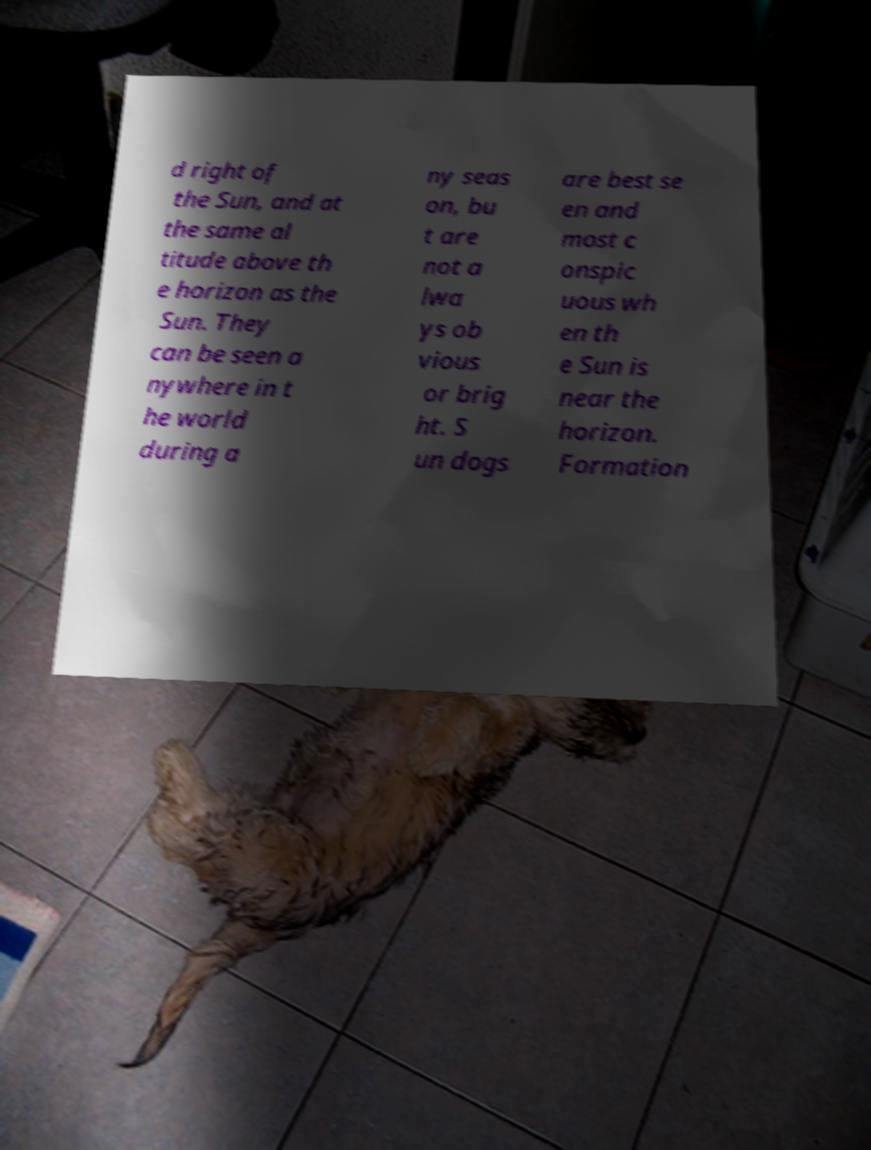Please identify and transcribe the text found in this image. d right of the Sun, and at the same al titude above th e horizon as the Sun. They can be seen a nywhere in t he world during a ny seas on, bu t are not a lwa ys ob vious or brig ht. S un dogs are best se en and most c onspic uous wh en th e Sun is near the horizon. Formation 